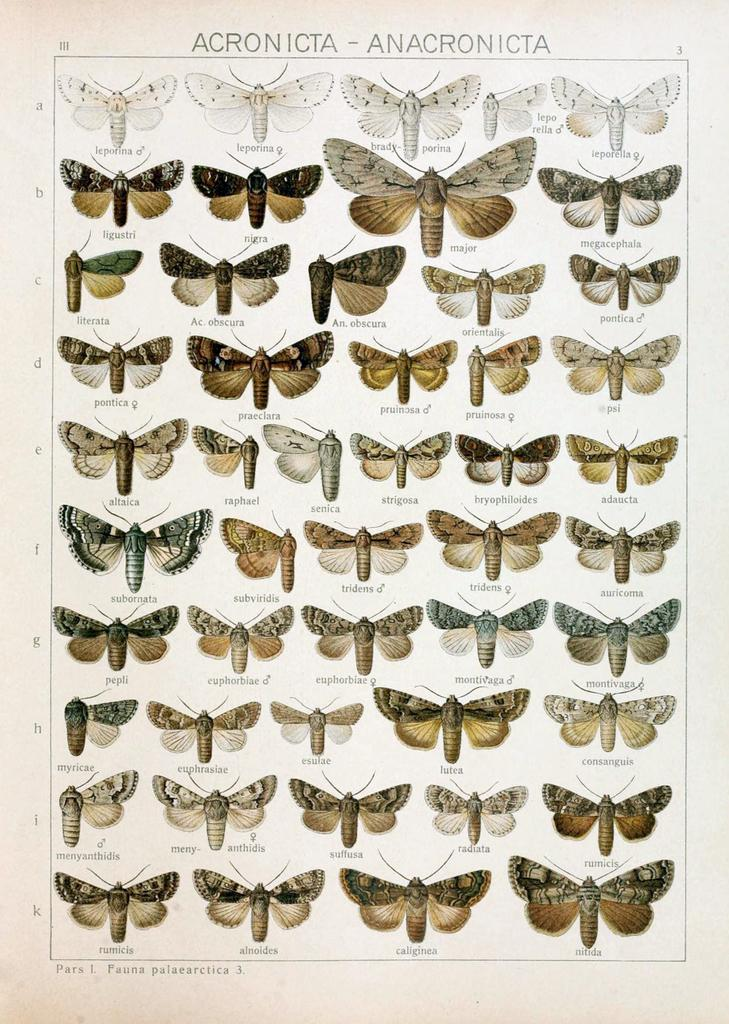What is present in the image that can be written on? There is a paper in the image that can be written on. What can be found on the paper? Something is written on the paper, and there are images of butterflies on it. What color is the hat worn by the eye in the image? There is no hat or eye present in the image; it only features a paper with writing and butterfly images. 